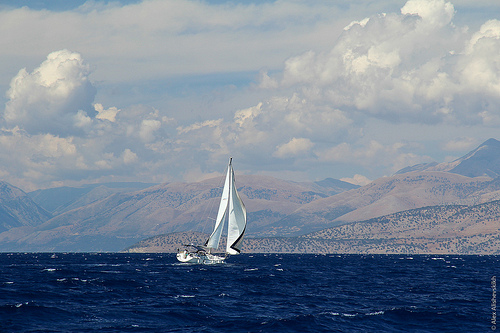What type of boat is shown in the image? The boat in the image is a sailboat, distinguished by its large white sails which are used to harness wind power for navigation. 